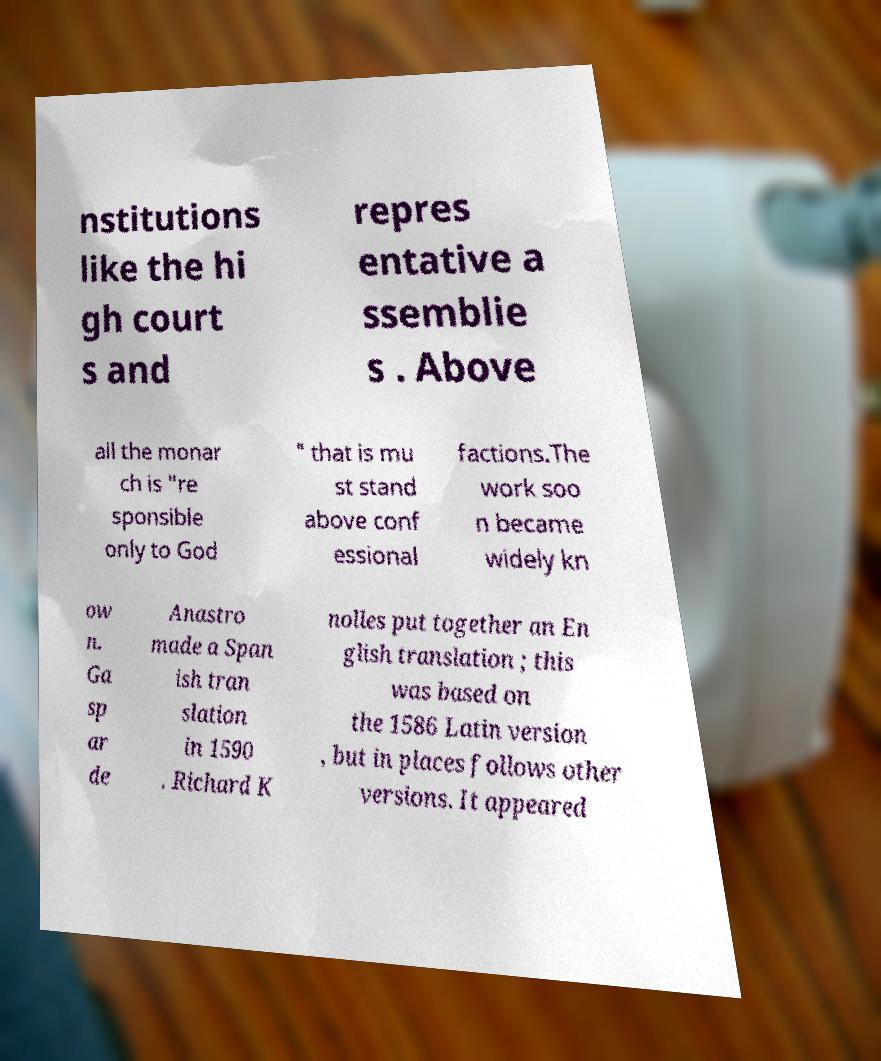What messages or text are displayed in this image? I need them in a readable, typed format. nstitutions like the hi gh court s and repres entative a ssemblie s . Above all the monar ch is "re sponsible only to God " that is mu st stand above conf essional factions.The work soo n became widely kn ow n. Ga sp ar de Anastro made a Span ish tran slation in 1590 . Richard K nolles put together an En glish translation ; this was based on the 1586 Latin version , but in places follows other versions. It appeared 